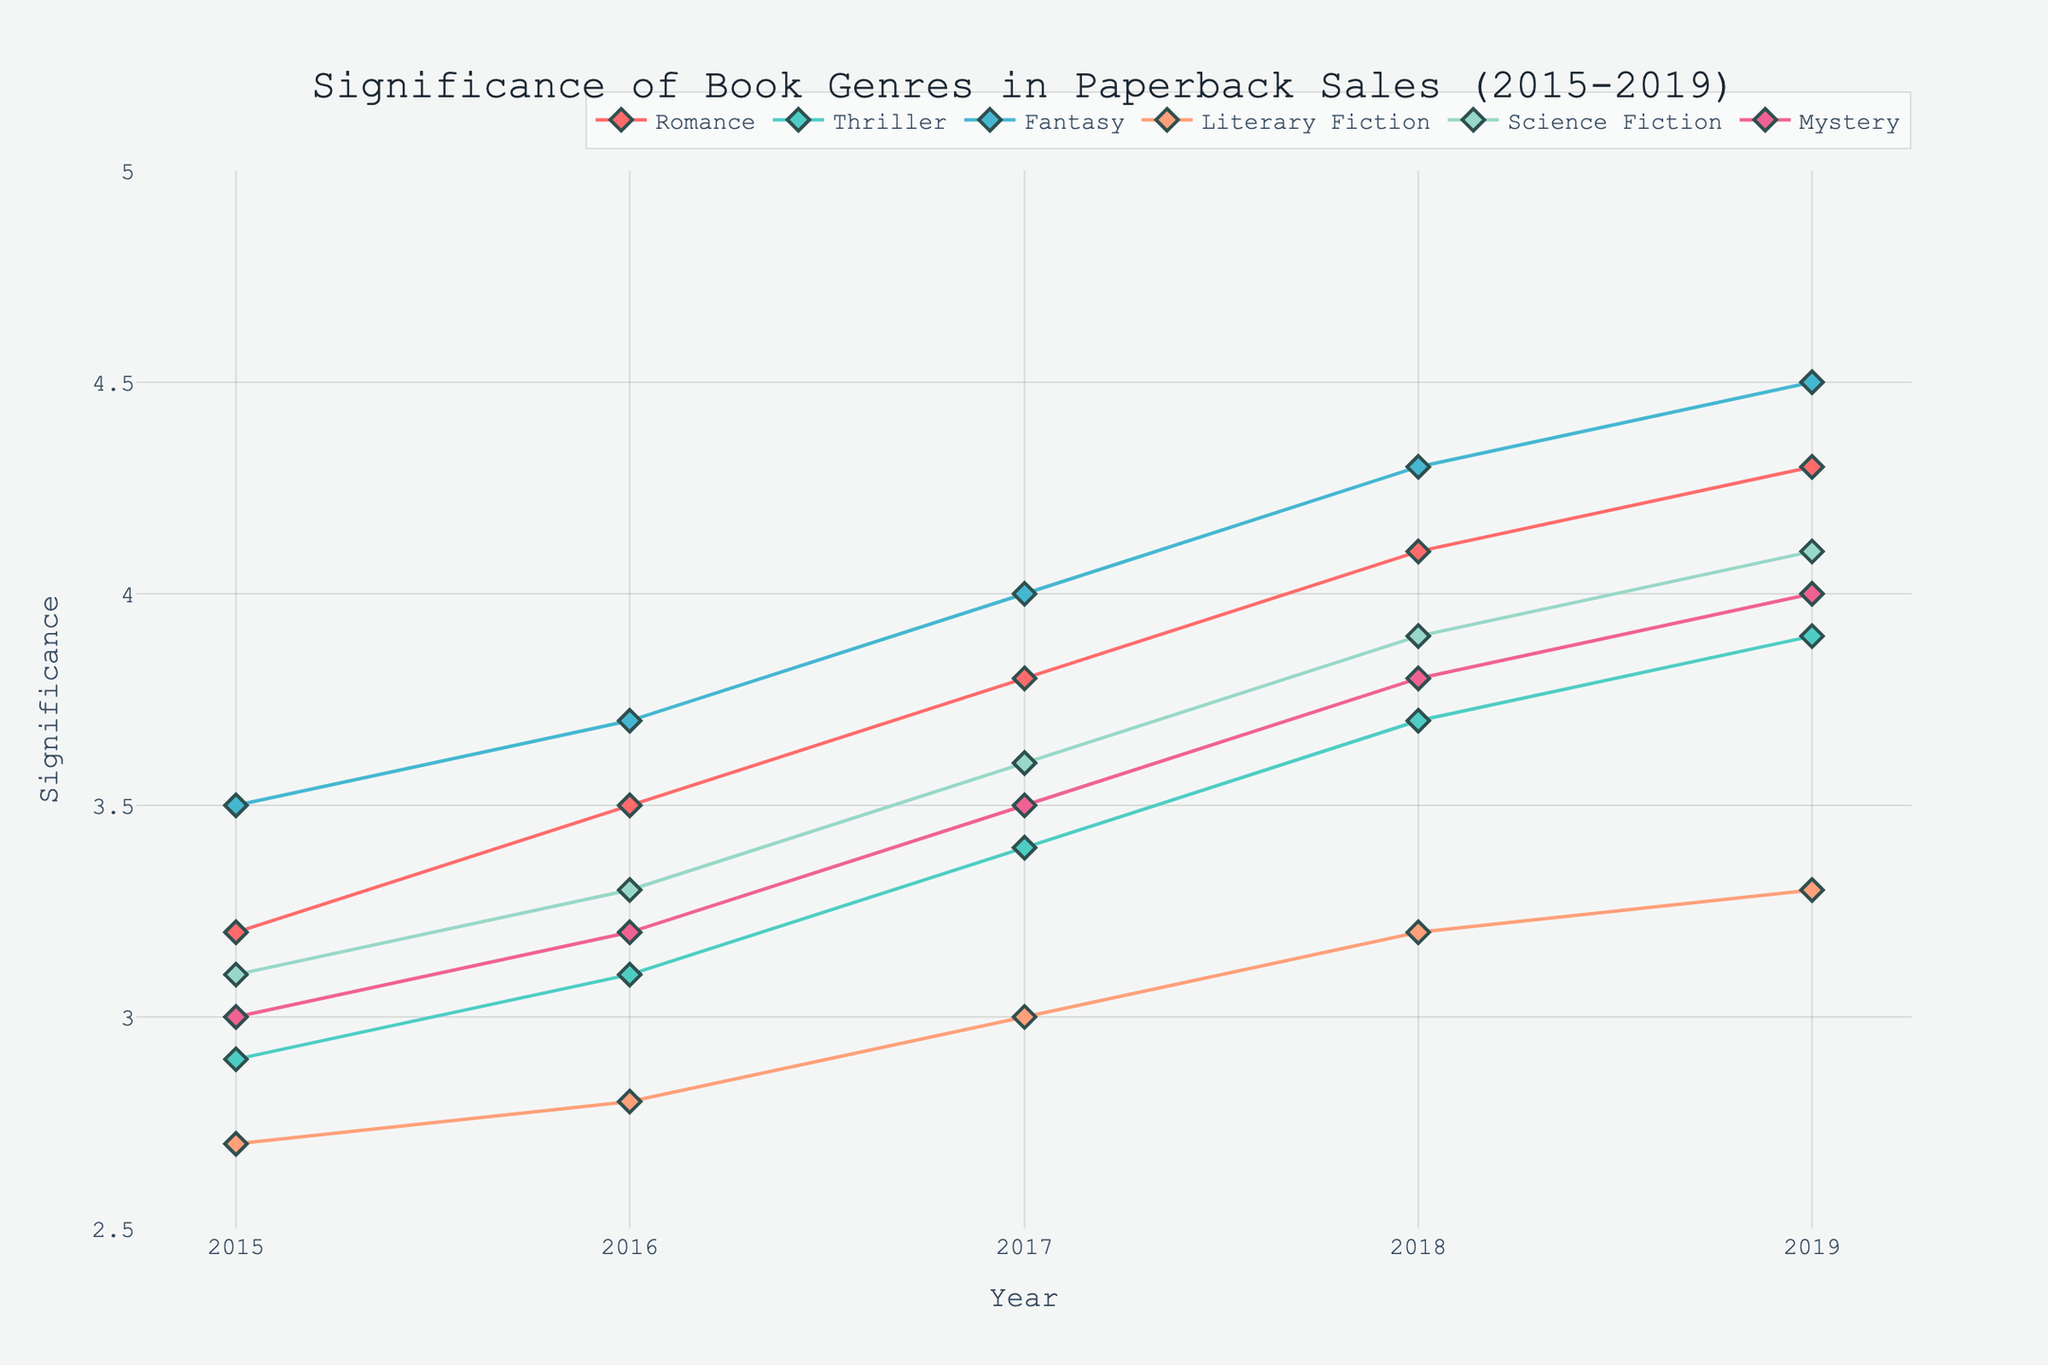What's the title of the figure? The title is usually captioned at the top of the figure and is used to describe the content and focus of the plot. Here, the title is: "Significance of Book Genres in Paperback Sales (2015-2019)"
Answer: Significance of Book Genres in Paperback Sales (2015-2019) Which genre shows the highest significance value in 2019? To find this, locate the data points at the year 2019 and compare their y-values. The highest point in 2019 is for Fantasy, which is at 4.5.
Answer: Fantasy What is the range of years shown in the plot? The x-axis represents time in years. The labels start from 2015 and end in 2019.
Answer: 2015-2019 Which genre shows the least increase in significance from 2015 to 2019? Calculate the difference in significance values from 2015 to 2019 for each genre and compare. Literary Fiction shows an increase from 2.7 to 3.3, which is the least increment of 0.6.
Answer: Literary Fiction How many genres are represented in the figure? Count the unique labels in the legend of the plot, which lists all the genres. There are six genres: Romance, Thriller, Fantasy, Literary Fiction, Science Fiction, and Mystery.
Answer: 6 Between which years does the Thriller genre show the greatest increase in significance? Check the y-values for Thriller from year to year and identify the largest jump. From 2017 to 2018, it increases from 3.4 to 3.7, which is a jump of 0.3.
Answer: 2017 to 2018 What is the significance value of Science Fiction in 2017? Look at the data point for Science Fiction in the year 2017; it's situated at 3.6.
Answer: 3.6 Compare the significance trends of Romance and Mystery from 2015 to 2019. Which has a steeper increase? Calculate the change in y-values for both genres from 2015 to 2019. Romance increases by (4.3 - 3.2) = 1.1, and Mystery increases by (4.0 - 3.0) = 1.0. Therefore, Romance has a steeper increase.
Answer: Romance Which genre has the most consistent increase in significance over the years? A consistent increase means the slope remains relatively steady across years. Fantasy shows a smooth and steady rise every year from 3.5 (2015) to 4.5 (2019).
Answer: Fantasy 